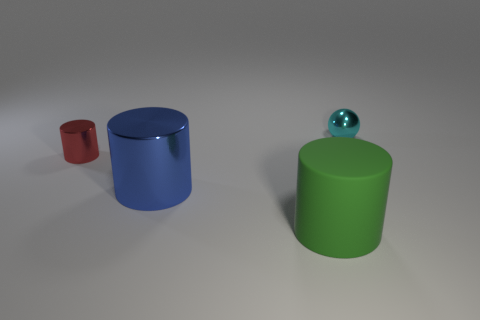Subtract all shiny cylinders. How many cylinders are left? 1 Add 2 small brown shiny objects. How many objects exist? 6 Subtract all spheres. How many objects are left? 3 Subtract all brown cylinders. Subtract all blue spheres. How many cylinders are left? 3 Add 3 small balls. How many small balls are left? 4 Add 1 small cyan shiny spheres. How many small cyan shiny spheres exist? 2 Subtract 0 purple spheres. How many objects are left? 4 Subtract all tiny cyan metallic things. Subtract all green matte things. How many objects are left? 2 